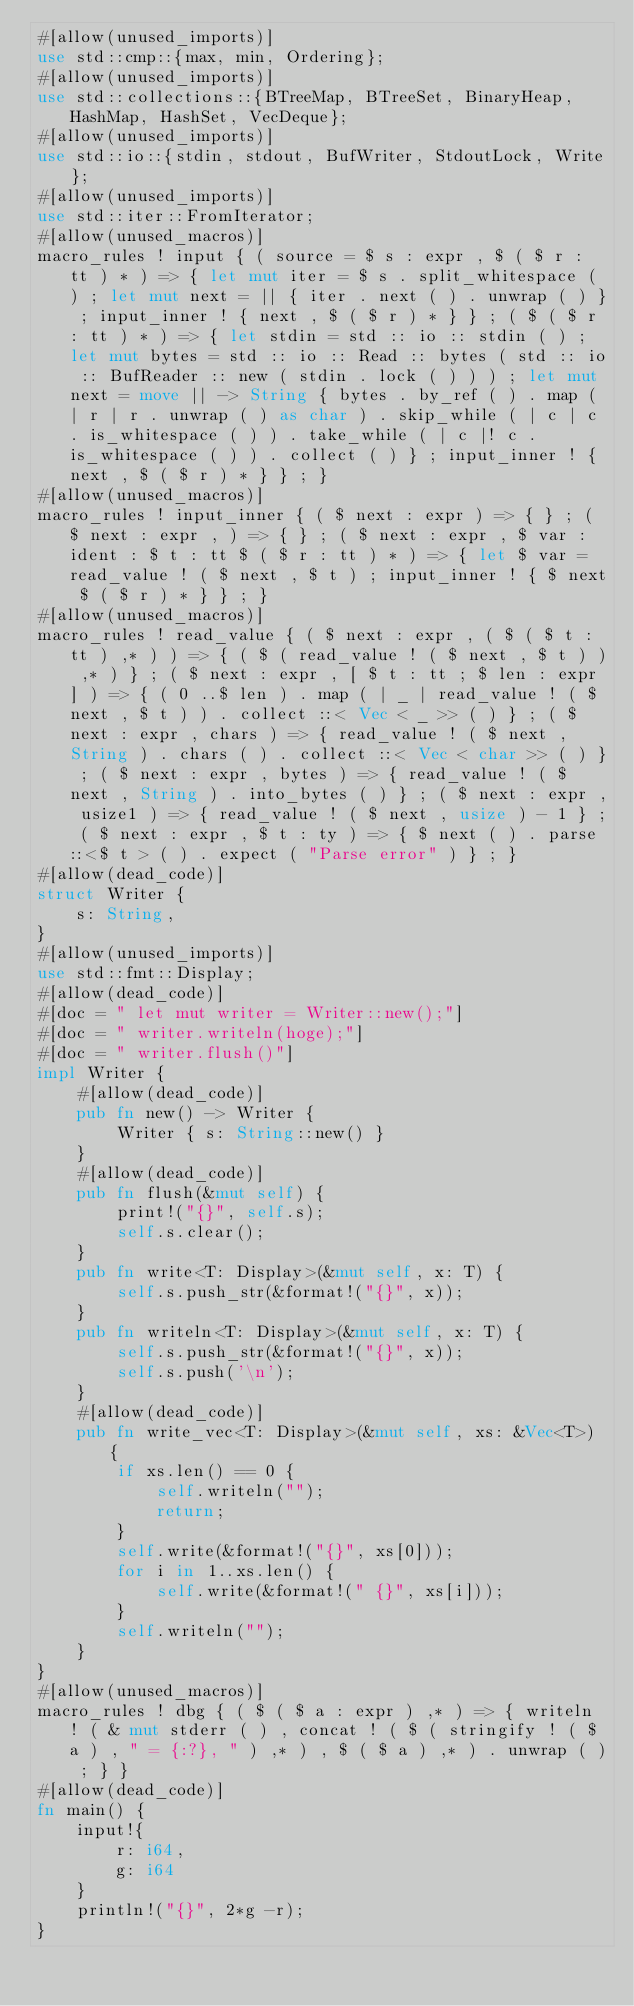<code> <loc_0><loc_0><loc_500><loc_500><_Rust_>#[allow(unused_imports)]
use std::cmp::{max, min, Ordering};
#[allow(unused_imports)]
use std::collections::{BTreeMap, BTreeSet, BinaryHeap, HashMap, HashSet, VecDeque};
#[allow(unused_imports)]
use std::io::{stdin, stdout, BufWriter, StdoutLock, Write};
#[allow(unused_imports)]
use std::iter::FromIterator;
#[allow(unused_macros)]
macro_rules ! input { ( source = $ s : expr , $ ( $ r : tt ) * ) => { let mut iter = $ s . split_whitespace ( ) ; let mut next = || { iter . next ( ) . unwrap ( ) } ; input_inner ! { next , $ ( $ r ) * } } ; ( $ ( $ r : tt ) * ) => { let stdin = std :: io :: stdin ( ) ; let mut bytes = std :: io :: Read :: bytes ( std :: io :: BufReader :: new ( stdin . lock ( ) ) ) ; let mut next = move || -> String { bytes . by_ref ( ) . map ( | r | r . unwrap ( ) as char ) . skip_while ( | c | c . is_whitespace ( ) ) . take_while ( | c |! c . is_whitespace ( ) ) . collect ( ) } ; input_inner ! { next , $ ( $ r ) * } } ; }
#[allow(unused_macros)]
macro_rules ! input_inner { ( $ next : expr ) => { } ; ( $ next : expr , ) => { } ; ( $ next : expr , $ var : ident : $ t : tt $ ( $ r : tt ) * ) => { let $ var = read_value ! ( $ next , $ t ) ; input_inner ! { $ next $ ( $ r ) * } } ; }
#[allow(unused_macros)]
macro_rules ! read_value { ( $ next : expr , ( $ ( $ t : tt ) ,* ) ) => { ( $ ( read_value ! ( $ next , $ t ) ) ,* ) } ; ( $ next : expr , [ $ t : tt ; $ len : expr ] ) => { ( 0 ..$ len ) . map ( | _ | read_value ! ( $ next , $ t ) ) . collect ::< Vec < _ >> ( ) } ; ( $ next : expr , chars ) => { read_value ! ( $ next , String ) . chars ( ) . collect ::< Vec < char >> ( ) } ; ( $ next : expr , bytes ) => { read_value ! ( $ next , String ) . into_bytes ( ) } ; ( $ next : expr , usize1 ) => { read_value ! ( $ next , usize ) - 1 } ; ( $ next : expr , $ t : ty ) => { $ next ( ) . parse ::<$ t > ( ) . expect ( "Parse error" ) } ; }
#[allow(dead_code)]
struct Writer {
    s: String,
}
#[allow(unused_imports)]
use std::fmt::Display;
#[allow(dead_code)]
#[doc = " let mut writer = Writer::new();"]
#[doc = " writer.writeln(hoge);"]
#[doc = " writer.flush()"]
impl Writer {
    #[allow(dead_code)]
    pub fn new() -> Writer {
        Writer { s: String::new() }
    }
    #[allow(dead_code)]
    pub fn flush(&mut self) {
        print!("{}", self.s);
        self.s.clear();
    }
    pub fn write<T: Display>(&mut self, x: T) {
        self.s.push_str(&format!("{}", x));
    }
    pub fn writeln<T: Display>(&mut self, x: T) {
        self.s.push_str(&format!("{}", x));
        self.s.push('\n');
    }
    #[allow(dead_code)]
    pub fn write_vec<T: Display>(&mut self, xs: &Vec<T>) {
        if xs.len() == 0 {
            self.writeln("");
            return;
        }
        self.write(&format!("{}", xs[0]));
        for i in 1..xs.len() {
            self.write(&format!(" {}", xs[i]));
        }
        self.writeln("");
    }
}
#[allow(unused_macros)]
macro_rules ! dbg { ( $ ( $ a : expr ) ,* ) => { writeln ! ( & mut stderr ( ) , concat ! ( $ ( stringify ! ( $ a ) , " = {:?}, " ) ,* ) , $ ( $ a ) ,* ) . unwrap ( ) ; } }
#[allow(dead_code)]
fn main() {
    input!{
        r: i64,
        g: i64
    }
    println!("{}", 2*g -r);
}</code> 